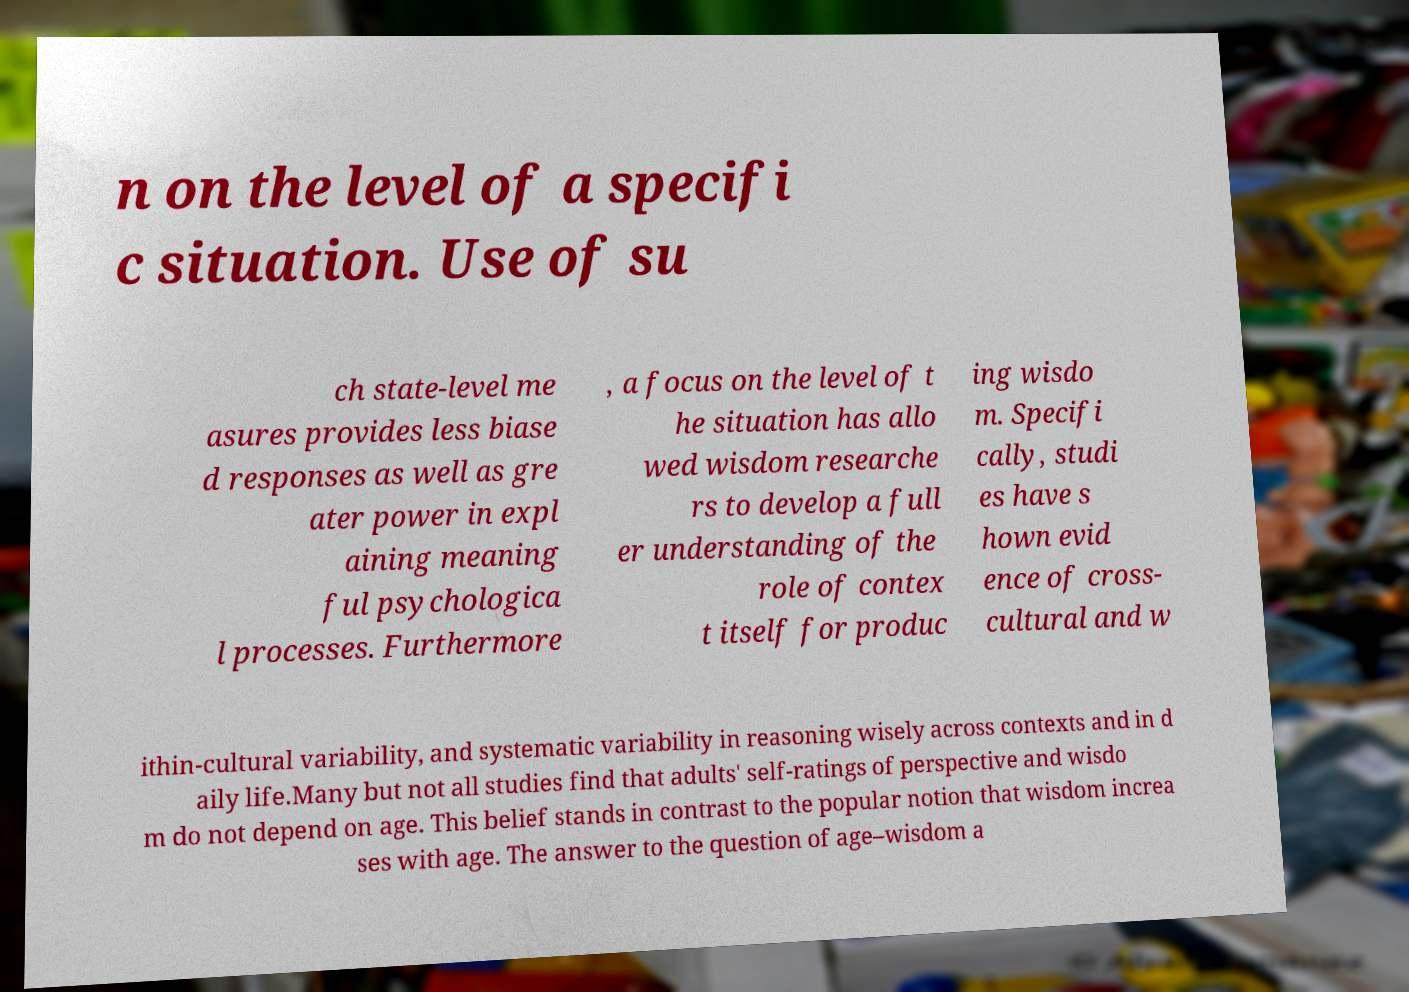Can you read and provide the text displayed in the image?This photo seems to have some interesting text. Can you extract and type it out for me? n on the level of a specifi c situation. Use of su ch state-level me asures provides less biase d responses as well as gre ater power in expl aining meaning ful psychologica l processes. Furthermore , a focus on the level of t he situation has allo wed wisdom researche rs to develop a full er understanding of the role of contex t itself for produc ing wisdo m. Specifi cally, studi es have s hown evid ence of cross- cultural and w ithin-cultural variability, and systematic variability in reasoning wisely across contexts and in d aily life.Many but not all studies find that adults' self-ratings of perspective and wisdo m do not depend on age. This belief stands in contrast to the popular notion that wisdom increa ses with age. The answer to the question of age–wisdom a 